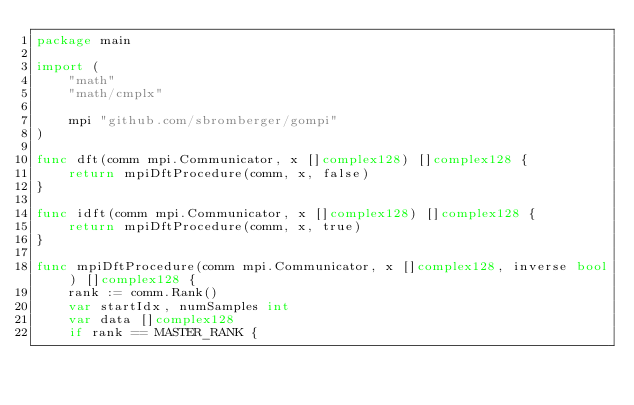<code> <loc_0><loc_0><loc_500><loc_500><_Go_>package main

import (
	"math"
	"math/cmplx"

	mpi "github.com/sbromberger/gompi"
)

func dft(comm mpi.Communicator, x []complex128) []complex128 {
	return mpiDftProcedure(comm, x, false)
}

func idft(comm mpi.Communicator, x []complex128) []complex128 {
	return mpiDftProcedure(comm, x, true)
}

func mpiDftProcedure(comm mpi.Communicator, x []complex128, inverse bool) []complex128 {
	rank := comm.Rank()
	var startIdx, numSamples int
	var data []complex128
	if rank == MASTER_RANK {</code> 